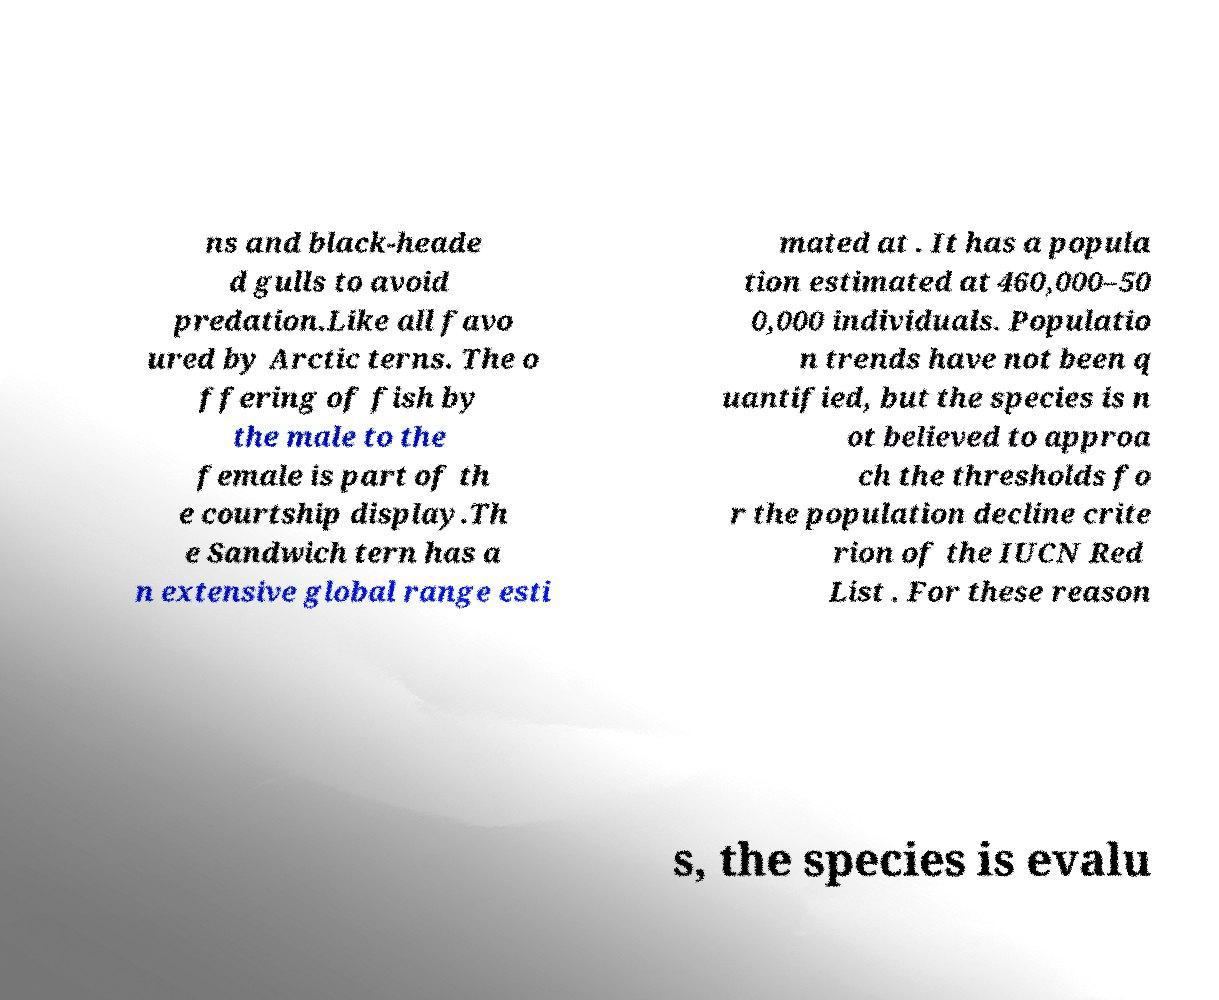There's text embedded in this image that I need extracted. Can you transcribe it verbatim? ns and black-heade d gulls to avoid predation.Like all favo ured by Arctic terns. The o ffering of fish by the male to the female is part of th e courtship display.Th e Sandwich tern has a n extensive global range esti mated at . It has a popula tion estimated at 460,000–50 0,000 individuals. Populatio n trends have not been q uantified, but the species is n ot believed to approa ch the thresholds fo r the population decline crite rion of the IUCN Red List . For these reason s, the species is evalu 